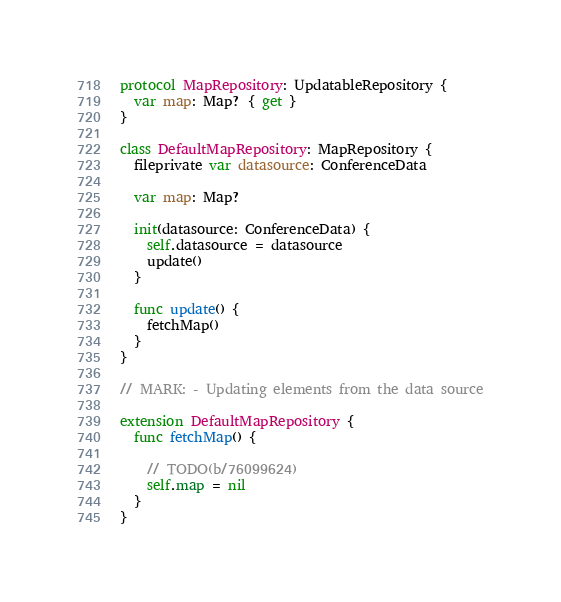<code> <loc_0><loc_0><loc_500><loc_500><_Swift_>
protocol MapRepository: UpdatableRepository {
  var map: Map? { get }
}

class DefaultMapRepository: MapRepository {
  fileprivate var datasource: ConferenceData

  var map: Map?

  init(datasource: ConferenceData) {
    self.datasource = datasource
    update()
  }

  func update() {
    fetchMap()
  }
}

// MARK: - Updating elements from the data source

extension DefaultMapRepository {
  func fetchMap() {

    // TODO(b/76099624)
    self.map = nil
  }
}
</code> 